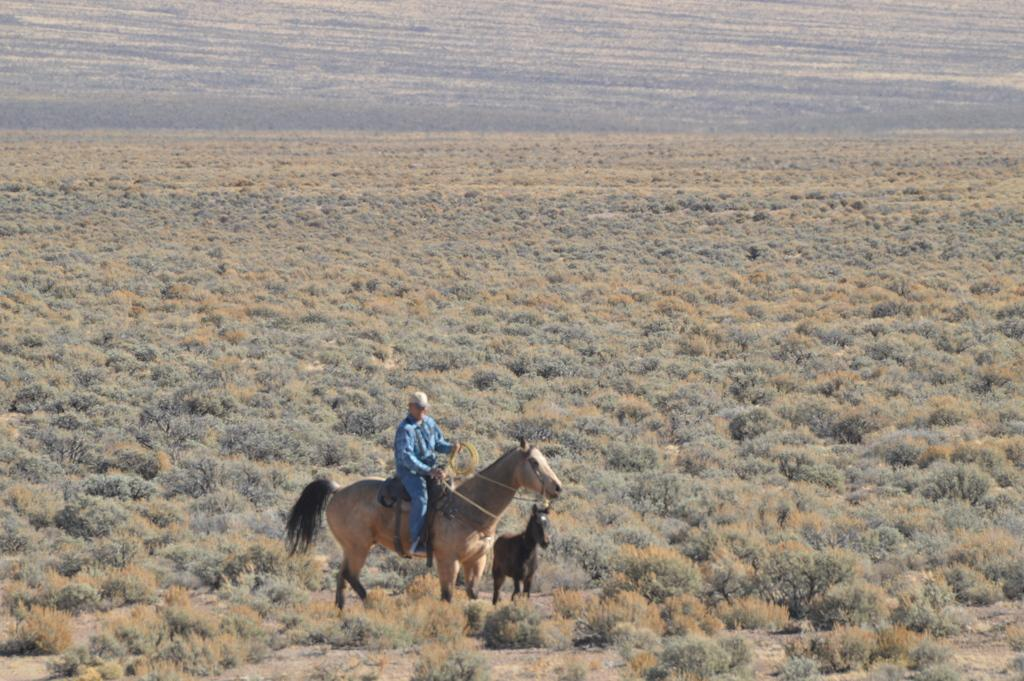What is the man doing in the image? The man is sitting on a horse. What is the man holding in the image? The man is holding a rope. What other living creatures can be seen in the image? There are animals visible in the image. What type of vegetation can be seen in the image? There are plants visible in the image. What type of gold jewelry is the man wearing in the image? There is no gold jewelry visible on the man in the image. Can you tell me how many airplanes are parked at the airport in the image? There is no airport or airplanes present in the image. 